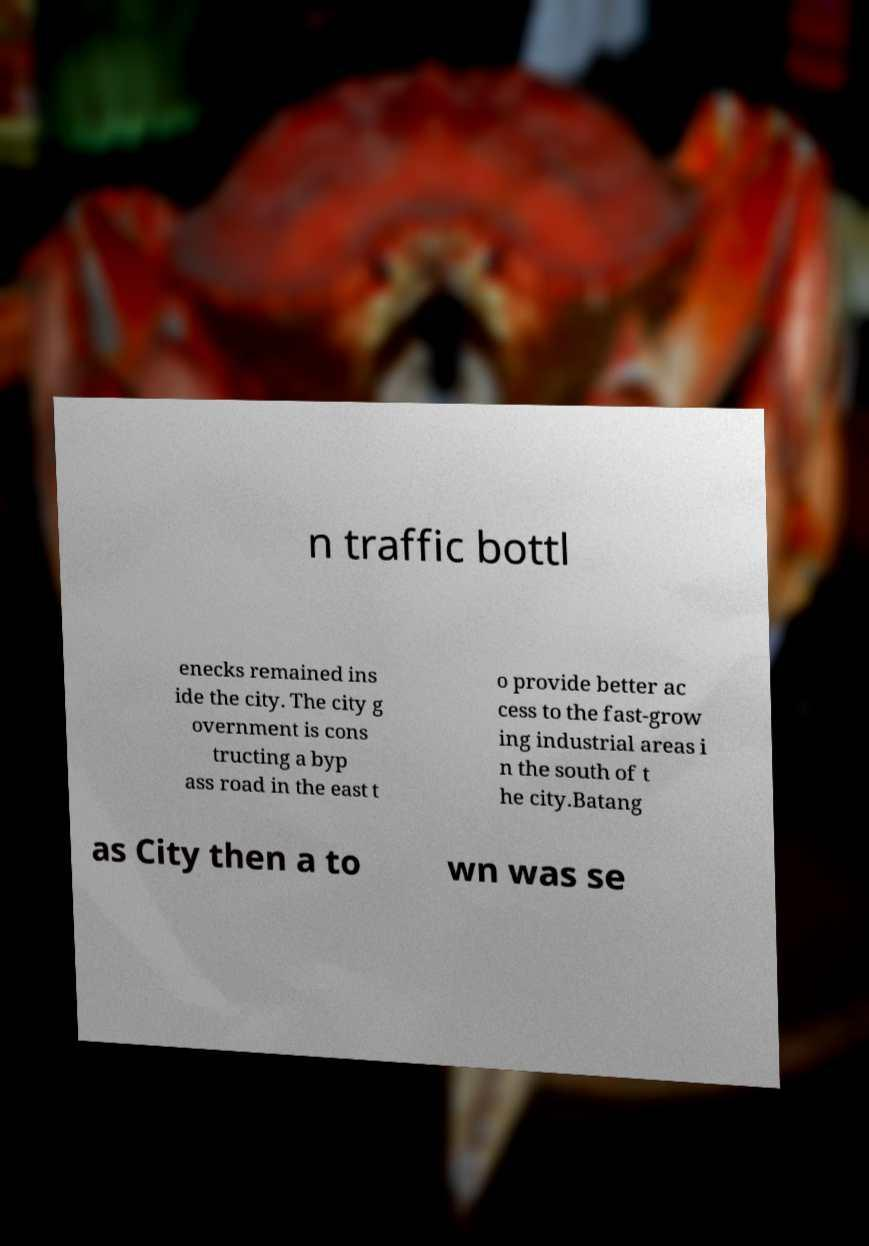There's text embedded in this image that I need extracted. Can you transcribe it verbatim? n traffic bottl enecks remained ins ide the city. The city g overnment is cons tructing a byp ass road in the east t o provide better ac cess to the fast-grow ing industrial areas i n the south of t he city.Batang as City then a to wn was se 